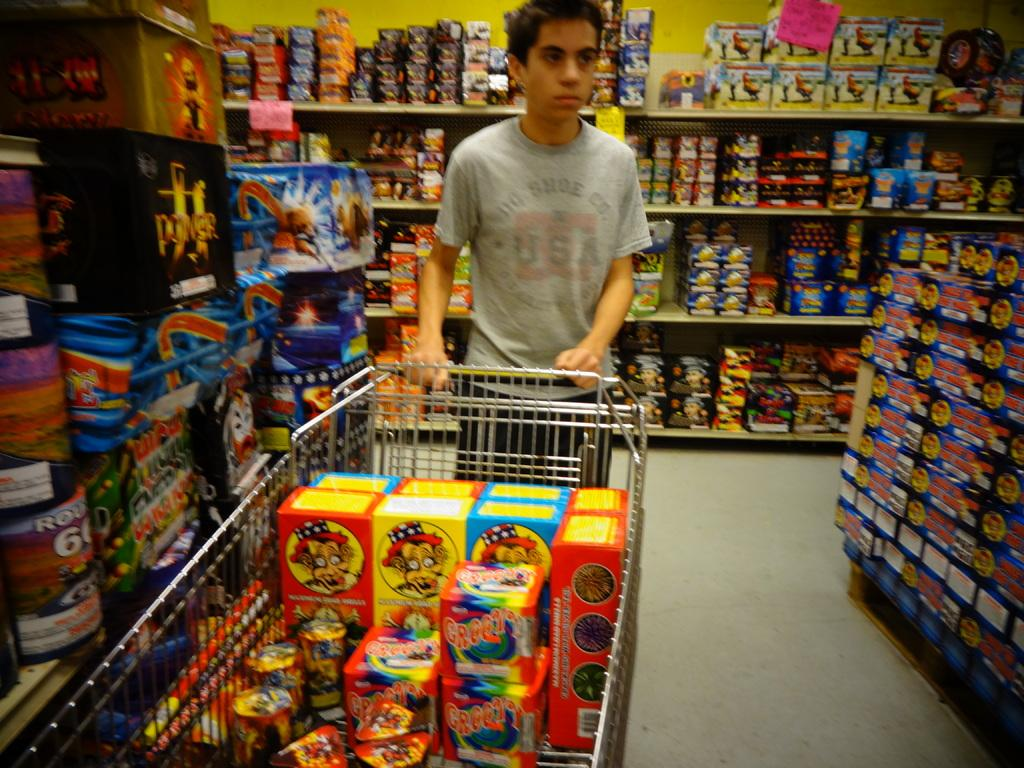What is the main subject of the image? There is a person standing in the image. Can you describe the person's appearance? The person is wearing clothes. What object can be seen near the person? There is a trolley in the image. What type of structure is visible in the image? There are shelves in the image. What is on the shelves? There are many things on the shelves. What is the surface that the person and trolley are standing on? There is a floor in the image. How much debt does the person have in the image? There is no information about the person's debt in the image. What type of cherry is being used as a decoration on the shelves? There are no cherries present in the image. 